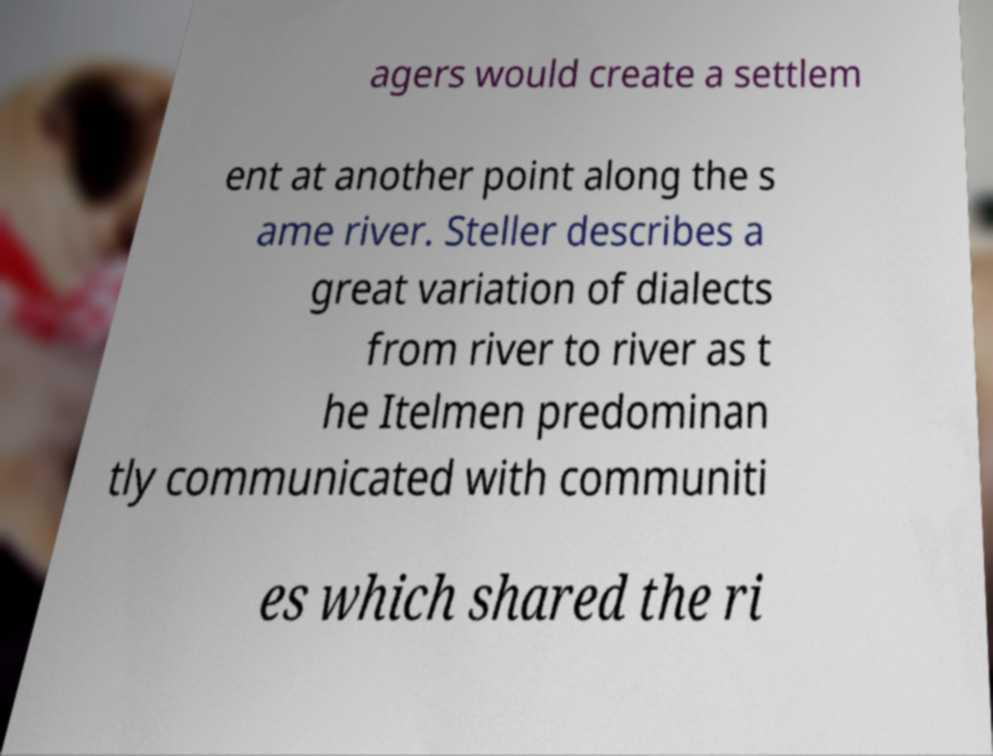For documentation purposes, I need the text within this image transcribed. Could you provide that? agers would create a settlem ent at another point along the s ame river. Steller describes a great variation of dialects from river to river as t he Itelmen predominan tly communicated with communiti es which shared the ri 